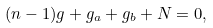Convert formula to latex. <formula><loc_0><loc_0><loc_500><loc_500>( n - 1 ) g + g _ { a } + g _ { b } + N = 0 ,</formula> 